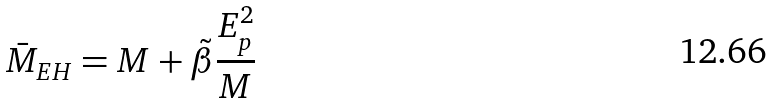Convert formula to latex. <formula><loc_0><loc_0><loc_500><loc_500>\bar { M } _ { E H } = M + \tilde { \beta } \frac { E _ { p } ^ { 2 } } { M }</formula> 